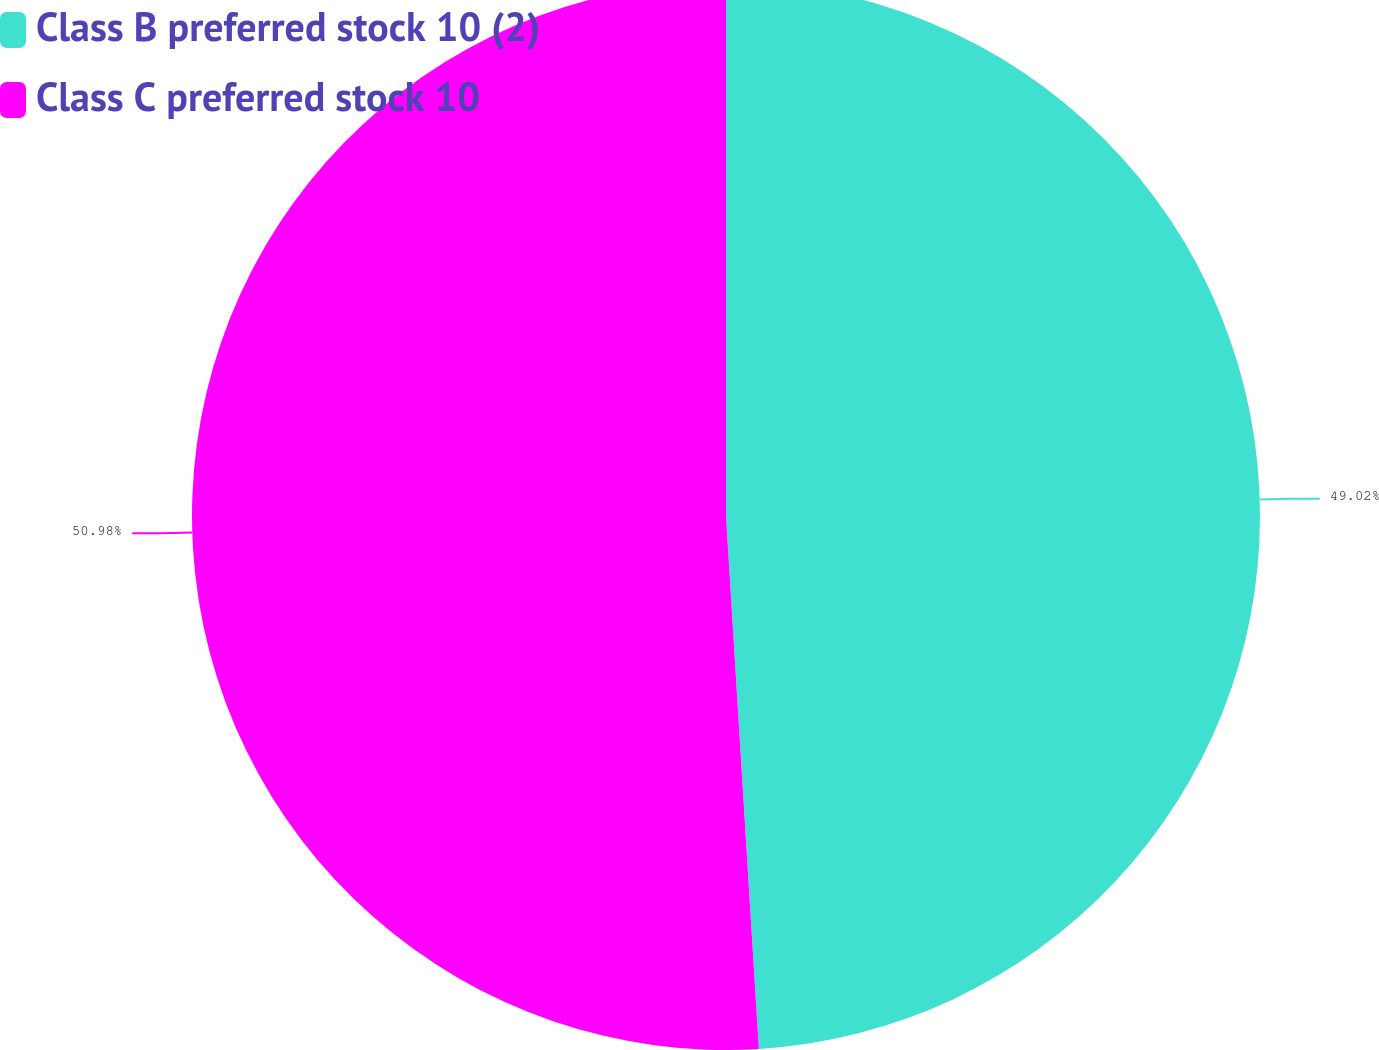<chart> <loc_0><loc_0><loc_500><loc_500><pie_chart><fcel>Class B preferred stock 10 (2)<fcel>Class C preferred stock 10<nl><fcel>49.02%<fcel>50.98%<nl></chart> 